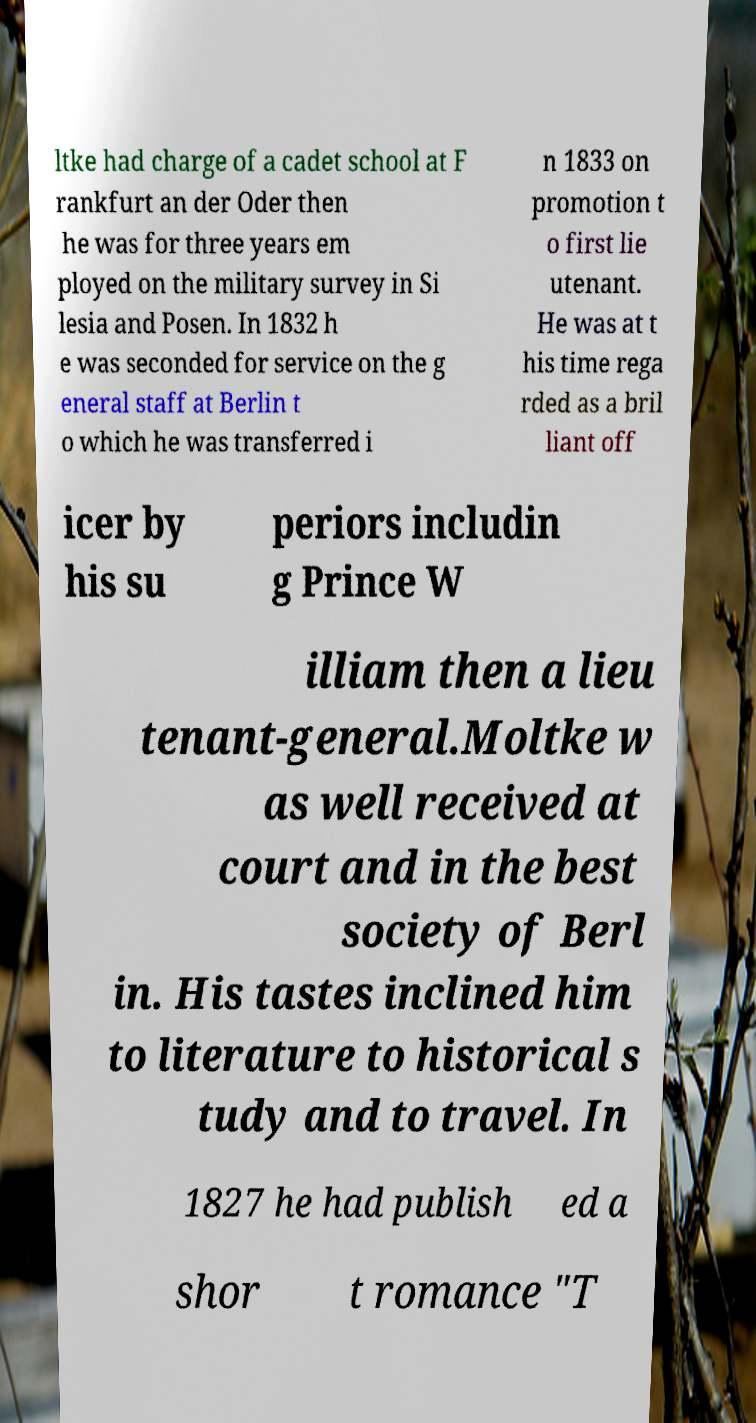What messages or text are displayed in this image? I need them in a readable, typed format. ltke had charge of a cadet school at F rankfurt an der Oder then he was for three years em ployed on the military survey in Si lesia and Posen. In 1832 h e was seconded for service on the g eneral staff at Berlin t o which he was transferred i n 1833 on promotion t o first lie utenant. He was at t his time rega rded as a bril liant off icer by his su periors includin g Prince W illiam then a lieu tenant-general.Moltke w as well received at court and in the best society of Berl in. His tastes inclined him to literature to historical s tudy and to travel. In 1827 he had publish ed a shor t romance "T 